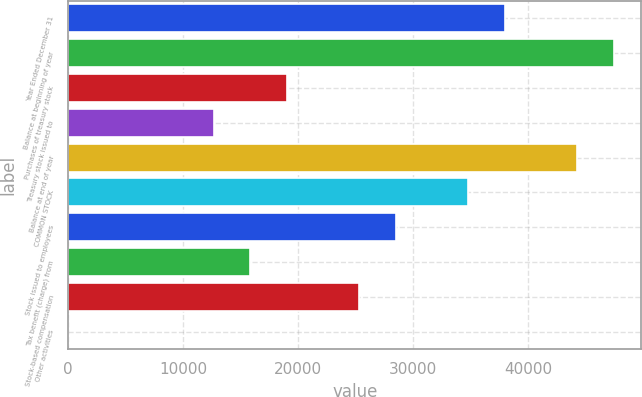Convert chart to OTSL. <chart><loc_0><loc_0><loc_500><loc_500><bar_chart><fcel>Year Ended December 31<fcel>Balance at beginning of year<fcel>Purchases of treasury stock<fcel>Treasury stock issued to<fcel>Balance at end of year<fcel>COMMON STOCK<fcel>Stock issued to employees<fcel>Tax benefit (charge) from<fcel>Stock-based compensation<fcel>Other activities<nl><fcel>37961.6<fcel>47451.5<fcel>18981.8<fcel>12655.2<fcel>44288.2<fcel>34798.3<fcel>28471.7<fcel>15818.5<fcel>25308.4<fcel>2<nl></chart> 